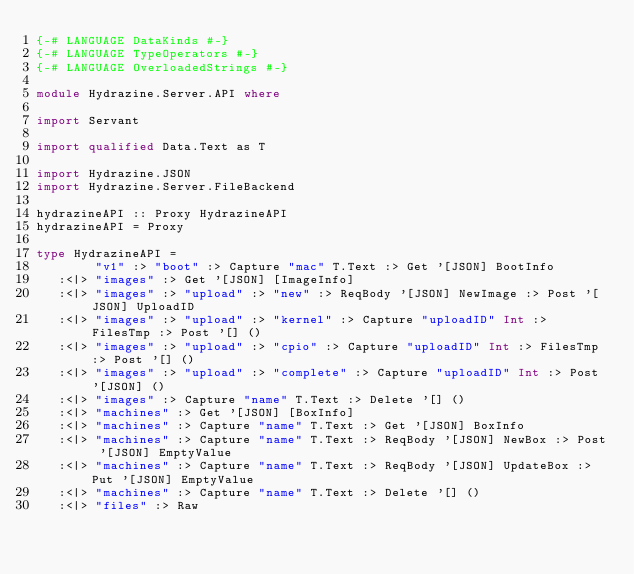<code> <loc_0><loc_0><loc_500><loc_500><_Haskell_>{-# LANGUAGE DataKinds #-}
{-# LANGUAGE TypeOperators #-}
{-# LANGUAGE OverloadedStrings #-}

module Hydrazine.Server.API where

import Servant

import qualified Data.Text as T

import Hydrazine.JSON
import Hydrazine.Server.FileBackend

hydrazineAPI :: Proxy HydrazineAPI
hydrazineAPI = Proxy

type HydrazineAPI =
        "v1" :> "boot" :> Capture "mac" T.Text :> Get '[JSON] BootInfo
   :<|> "images" :> Get '[JSON] [ImageInfo]
   :<|> "images" :> "upload" :> "new" :> ReqBody '[JSON] NewImage :> Post '[JSON] UploadID
   :<|> "images" :> "upload" :> "kernel" :> Capture "uploadID" Int :> FilesTmp :> Post '[] ()
   :<|> "images" :> "upload" :> "cpio" :> Capture "uploadID" Int :> FilesTmp :> Post '[] ()
   :<|> "images" :> "upload" :> "complete" :> Capture "uploadID" Int :> Post '[JSON] ()
   :<|> "images" :> Capture "name" T.Text :> Delete '[] ()
   :<|> "machines" :> Get '[JSON] [BoxInfo]
   :<|> "machines" :> Capture "name" T.Text :> Get '[JSON] BoxInfo
   :<|> "machines" :> Capture "name" T.Text :> ReqBody '[JSON] NewBox :> Post '[JSON] EmptyValue
   :<|> "machines" :> Capture "name" T.Text :> ReqBody '[JSON] UpdateBox :> Put '[JSON] EmptyValue
   :<|> "machines" :> Capture "name" T.Text :> Delete '[] ()
   :<|> "files" :> Raw
</code> 